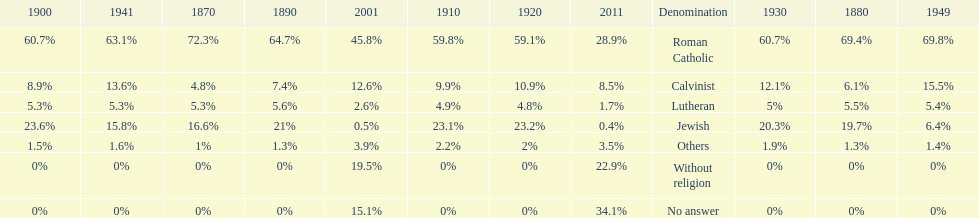The percentage of people who identified as calvinist was, at most, how much? 15.5%. 